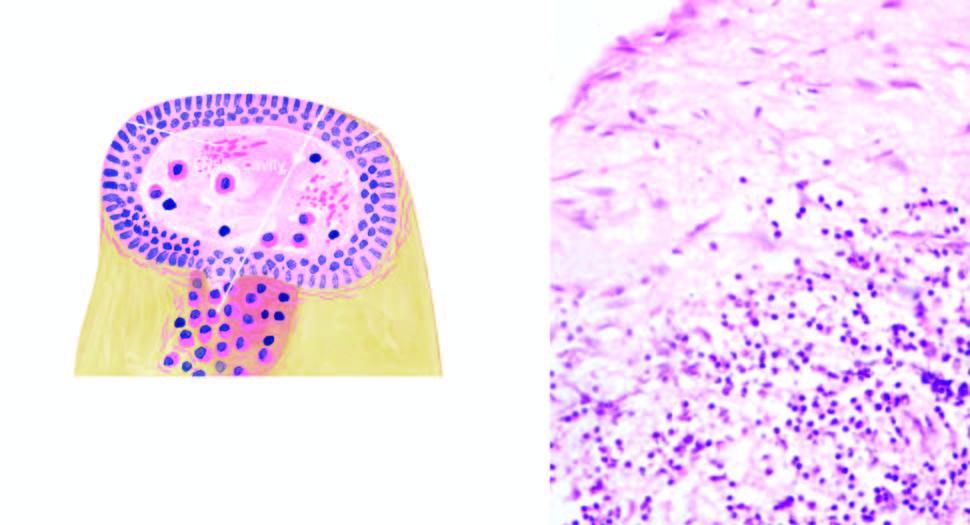what is the cyst wall densely infiltrated by?
Answer the question using a single word or phrase. Chronic inflammatory cells 